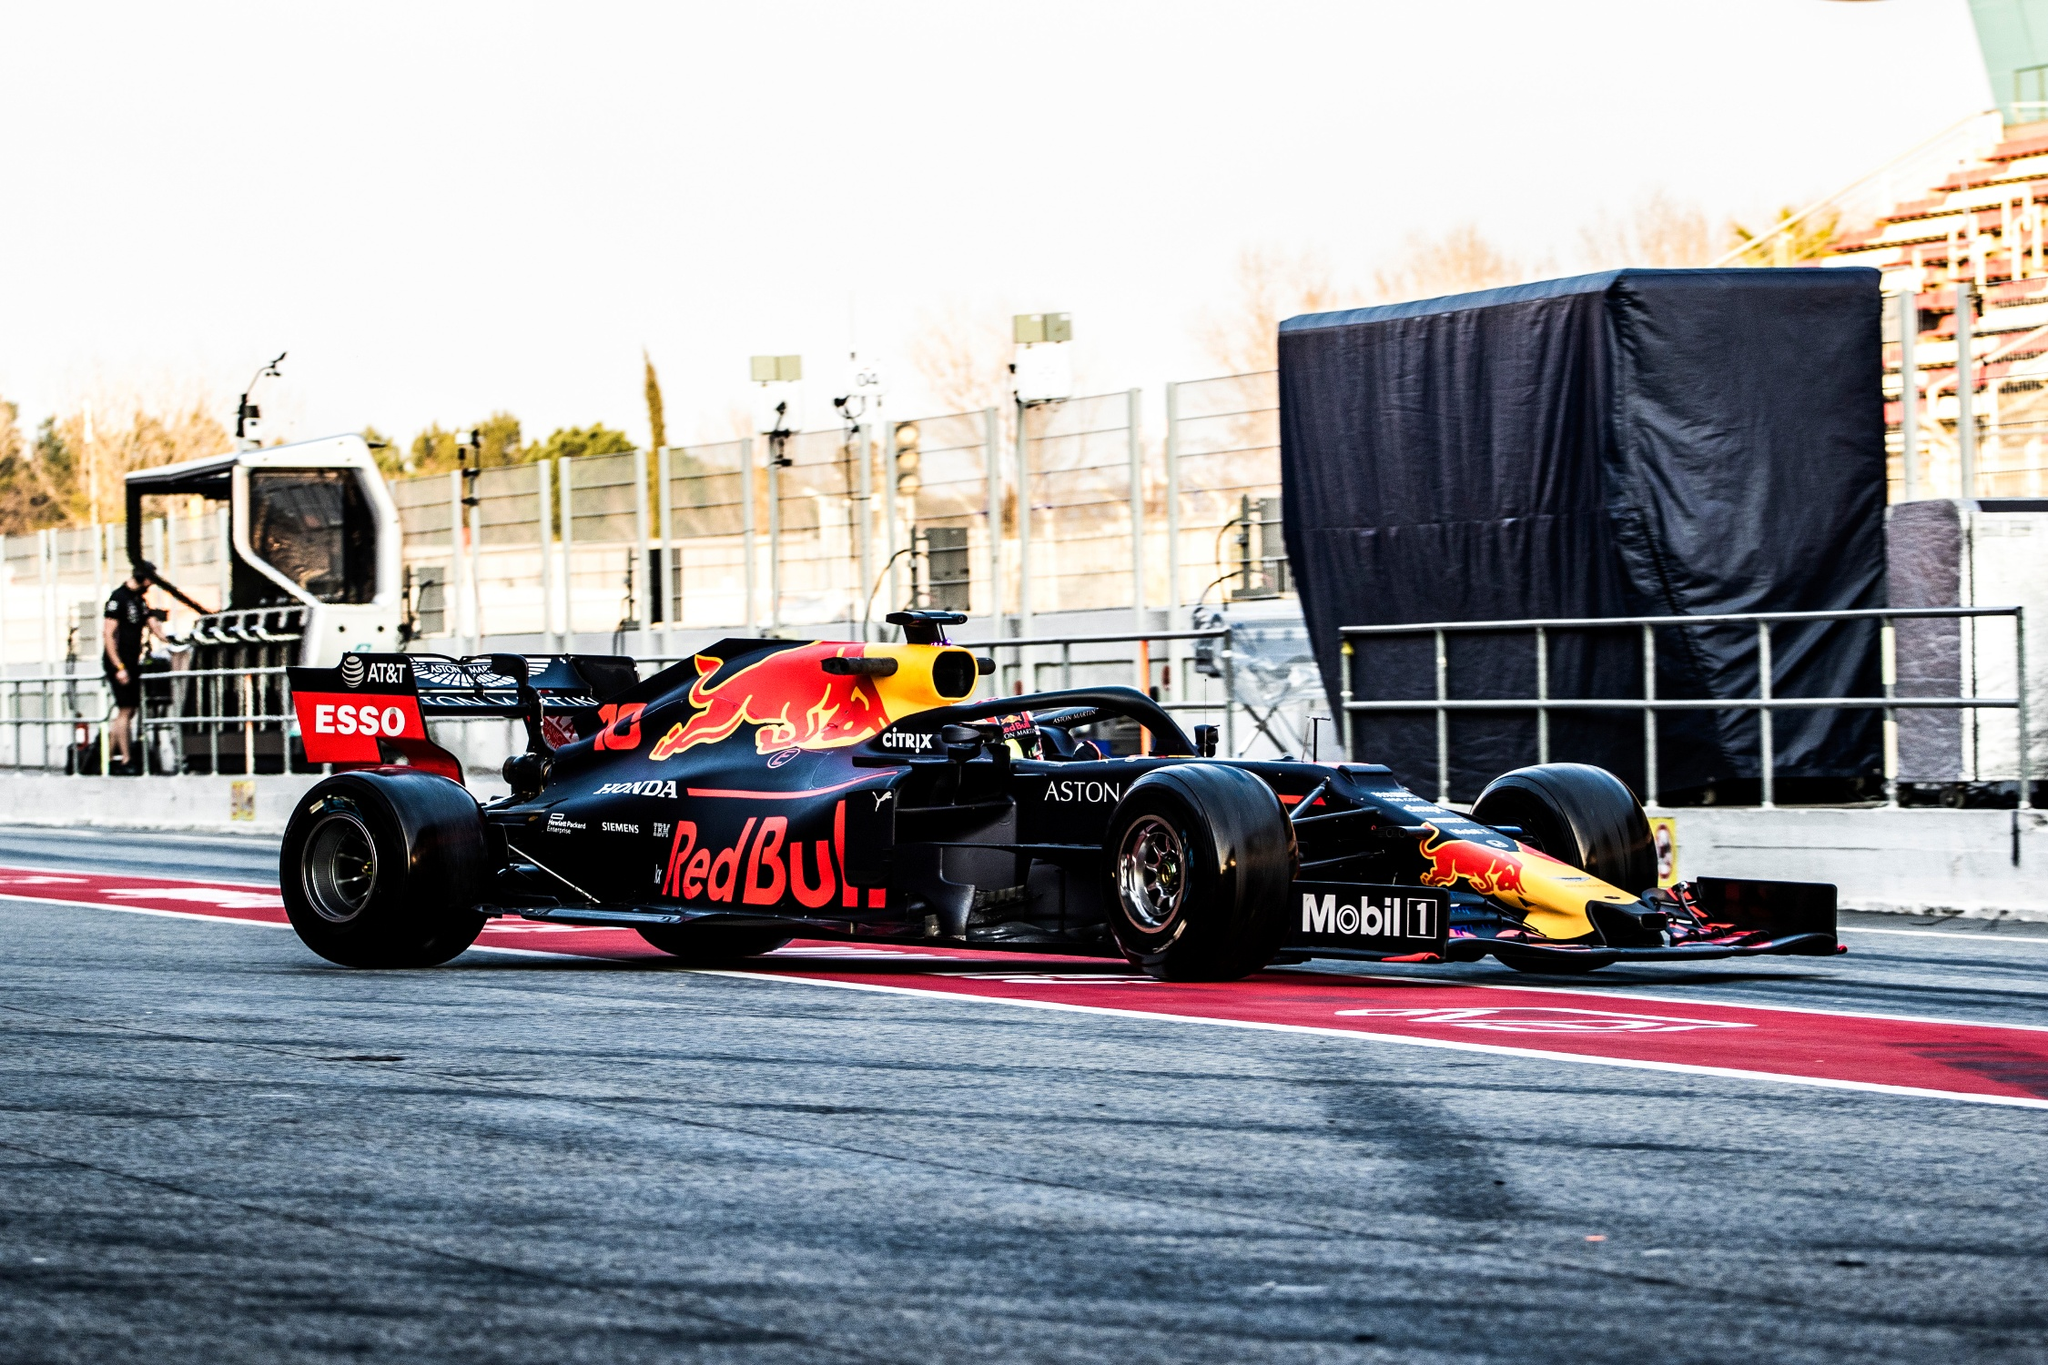Analyze the image in a comprehensive and detailed manner. The image showcases a high-energy scene on a Formula One race track. Dominating the foreground, a Red Bull Formula One car is captured in mid-motion. The car's livery is a striking combination of black, red, and yellow, with the iconic Red Bull logo prominently displayed on its side. The design includes sponsorship logos from numerous brands such as ESSEX and Mobil 1. The car appears to be just off the pit lane, indicated by the red and white markings on the track, which are typical of Formula One circuits.

On the left side of the image, there is a spectator or crew barrier made of fencing, ensuring safety within the vicinity of a high-speed vehicle. Behind the primary focus of the race car, various elements of the racing infrastructure are visible. A large structure, possibly a pit stop or part of the paddock, is covered in black fabric. This structure is usually used for maintenance and crew operations during the race.

There are crew members in the background along with equipment that appears to be a crane for utilitarian purposes, such as lifting vehicles or heavy gear. The atmosphere depicted is energetic and fast-paced, typical of the vicinity around a high-stakes Formula One event. 